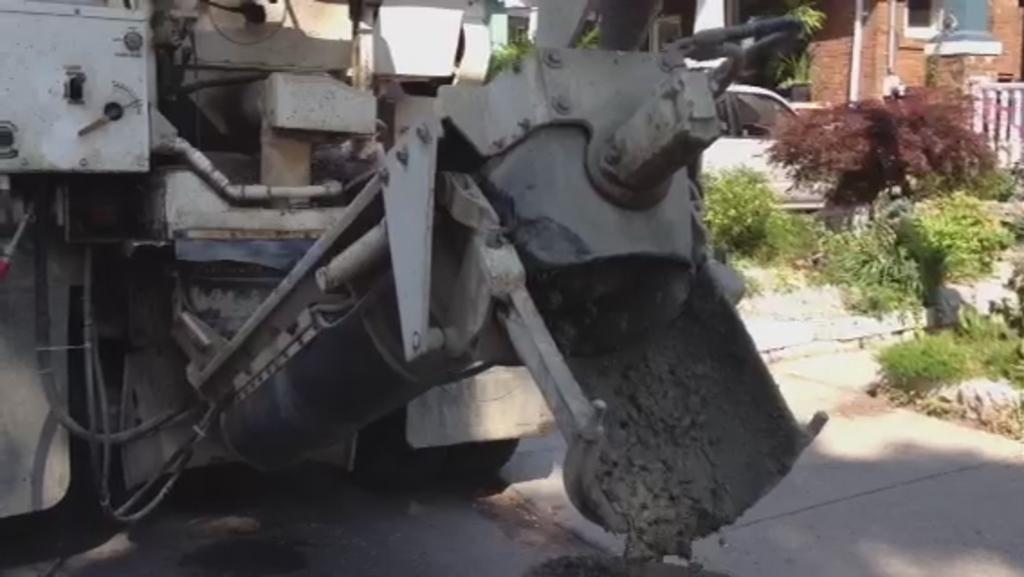Could you give a brief overview of what you see in this image? In this picture we can see a vehicle on the road, concrete, car, plants, pot, fence, pipe and in the background we can see a window and the wall. 